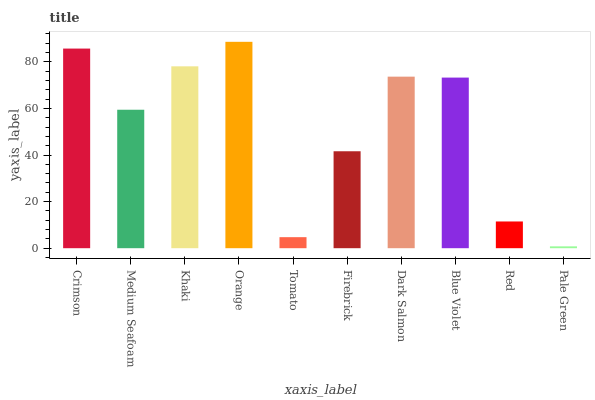Is Pale Green the minimum?
Answer yes or no. Yes. Is Orange the maximum?
Answer yes or no. Yes. Is Medium Seafoam the minimum?
Answer yes or no. No. Is Medium Seafoam the maximum?
Answer yes or no. No. Is Crimson greater than Medium Seafoam?
Answer yes or no. Yes. Is Medium Seafoam less than Crimson?
Answer yes or no. Yes. Is Medium Seafoam greater than Crimson?
Answer yes or no. No. Is Crimson less than Medium Seafoam?
Answer yes or no. No. Is Blue Violet the high median?
Answer yes or no. Yes. Is Medium Seafoam the low median?
Answer yes or no. Yes. Is Crimson the high median?
Answer yes or no. No. Is Khaki the low median?
Answer yes or no. No. 